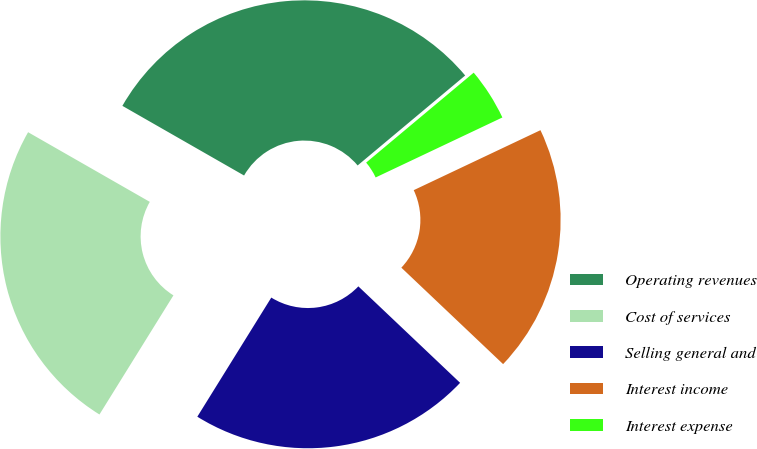Convert chart. <chart><loc_0><loc_0><loc_500><loc_500><pie_chart><fcel>Operating revenues<fcel>Cost of services<fcel>Selling general and<fcel>Interest income<fcel>Interest expense<nl><fcel>30.64%<fcel>24.43%<fcel>21.77%<fcel>19.11%<fcel>4.05%<nl></chart> 